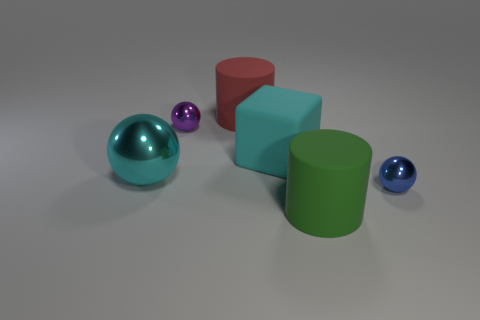There is a thing that is the same color as the rubber block; what is its shape?
Your response must be concise. Sphere. Are there any other large green objects that have the same shape as the large shiny object?
Offer a very short reply. No. The red thing that is the same size as the cyan matte block is what shape?
Give a very brief answer. Cylinder. What number of things are either small purple things or large rubber cubes?
Ensure brevity in your answer.  2. Are there any large cyan rubber cylinders?
Keep it short and to the point. No. Are there fewer large cyan blocks than small cyan metallic things?
Your response must be concise. No. Are there any red objects that have the same size as the cyan matte thing?
Your response must be concise. Yes. There is a purple shiny object; does it have the same shape as the large object that is on the left side of the big red cylinder?
Ensure brevity in your answer.  Yes. How many balls are green objects or big cyan objects?
Offer a very short reply. 1. Is the number of tiny metallic things greater than the number of spheres?
Your response must be concise. No. 